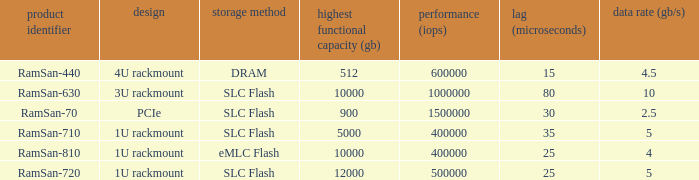What is the ramsan-810 transfer delay? 1.0. 